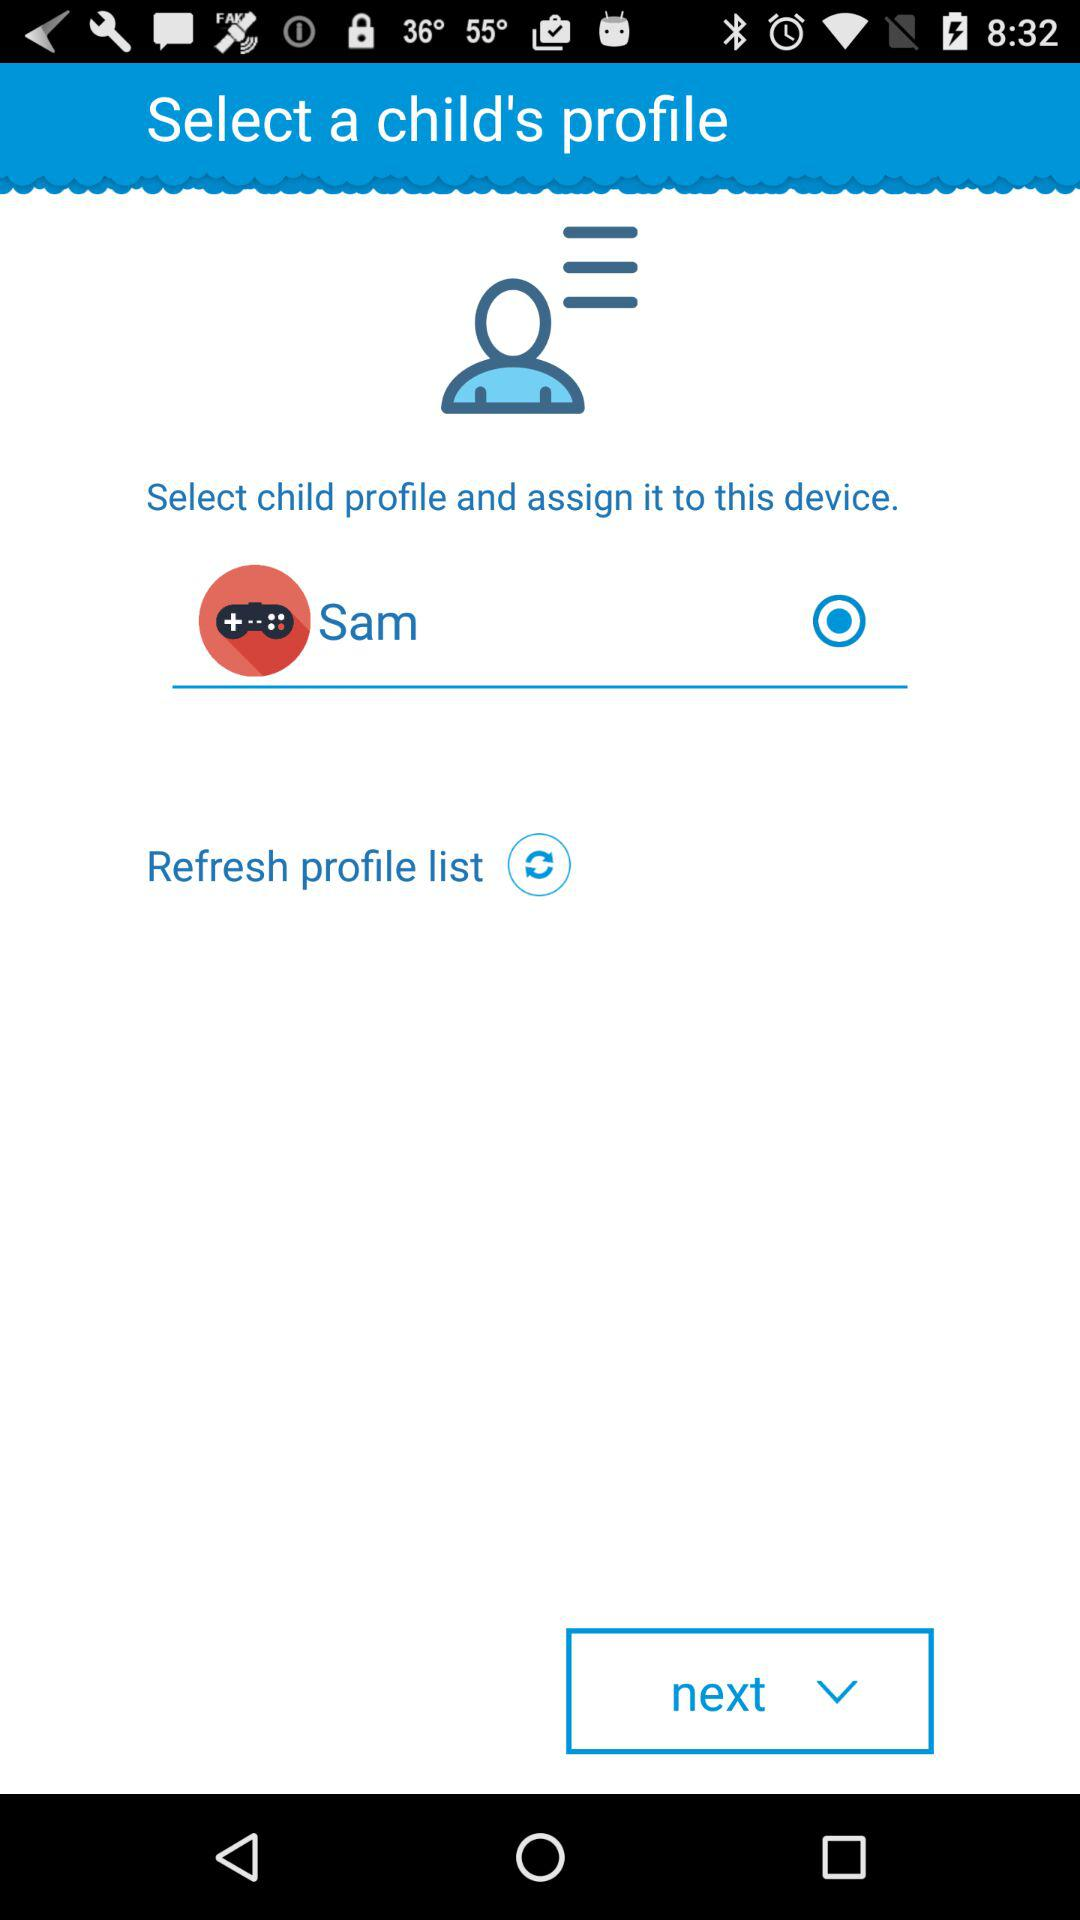Is Sam's profile selected or not? Sam's profile is selected. 